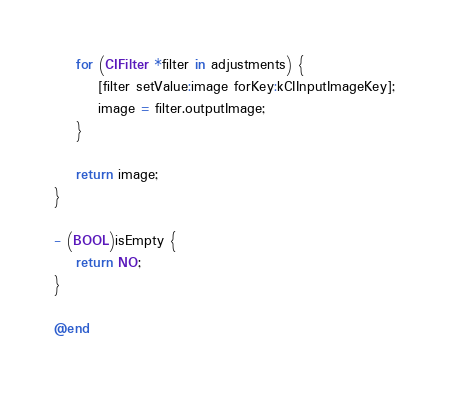Convert code to text. <code><loc_0><loc_0><loc_500><loc_500><_ObjectiveC_>    for (CIFilter *filter in adjustments) {
        [filter setValue:image forKey:kCIInputImageKey];
        image = filter.outputImage;
    }

    return image;
}

- (BOOL)isEmpty {
    return NO;
}

@end
</code> 